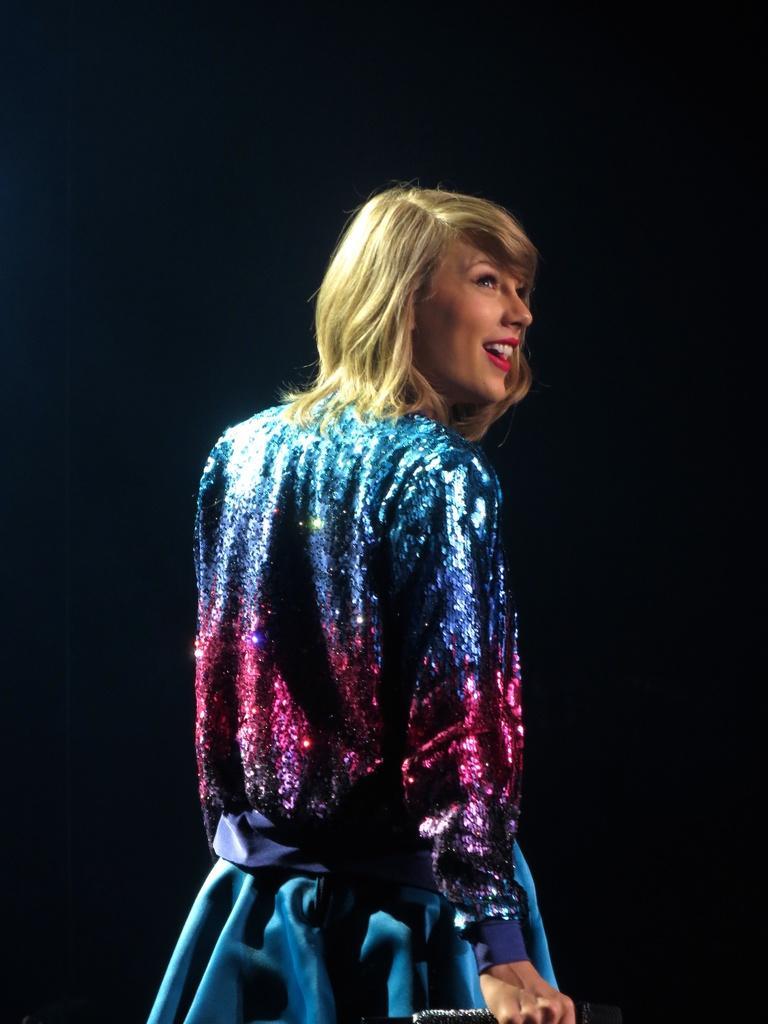In one or two sentences, can you explain what this image depicts? A woman is standing, she wore a blue color shining dress. 